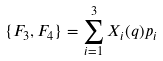Convert formula to latex. <formula><loc_0><loc_0><loc_500><loc_500>\{ F _ { 3 } , F _ { 4 } \} = \sum _ { i = 1 } ^ { 3 } X _ { i } ( { q } ) p _ { i }</formula> 